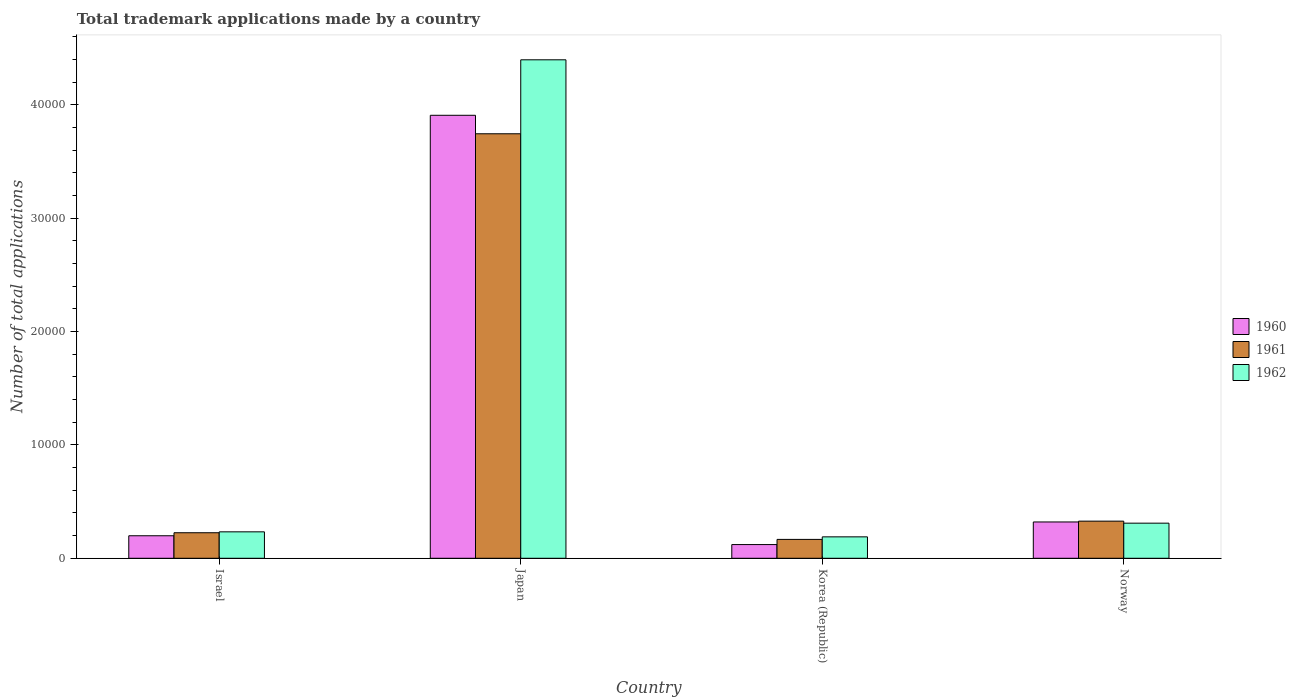How many groups of bars are there?
Ensure brevity in your answer.  4. Are the number of bars on each tick of the X-axis equal?
Your answer should be very brief. Yes. How many bars are there on the 4th tick from the right?
Offer a very short reply. 3. What is the label of the 1st group of bars from the left?
Your response must be concise. Israel. What is the number of applications made by in 1960 in Korea (Republic)?
Your response must be concise. 1209. Across all countries, what is the maximum number of applications made by in 1962?
Give a very brief answer. 4.40e+04. Across all countries, what is the minimum number of applications made by in 1960?
Your answer should be compact. 1209. In which country was the number of applications made by in 1960 minimum?
Ensure brevity in your answer.  Korea (Republic). What is the total number of applications made by in 1962 in the graph?
Keep it short and to the point. 5.13e+04. What is the difference between the number of applications made by in 1962 in Israel and that in Japan?
Keep it short and to the point. -4.17e+04. What is the difference between the number of applications made by in 1961 in Israel and the number of applications made by in 1960 in Norway?
Your answer should be very brief. -952. What is the average number of applications made by in 1962 per country?
Make the answer very short. 1.28e+04. What is the difference between the number of applications made by of/in 1960 and number of applications made by of/in 1961 in Israel?
Your answer should be compact. -266. In how many countries, is the number of applications made by in 1961 greater than 34000?
Make the answer very short. 1. What is the ratio of the number of applications made by in 1961 in Israel to that in Japan?
Your answer should be compact. 0.06. Is the difference between the number of applications made by in 1960 in Japan and Korea (Republic) greater than the difference between the number of applications made by in 1961 in Japan and Korea (Republic)?
Offer a very short reply. Yes. What is the difference between the highest and the second highest number of applications made by in 1960?
Make the answer very short. 3.71e+04. What is the difference between the highest and the lowest number of applications made by in 1961?
Keep it short and to the point. 3.58e+04. In how many countries, is the number of applications made by in 1960 greater than the average number of applications made by in 1960 taken over all countries?
Offer a terse response. 1. What does the 1st bar from the right in Israel represents?
Offer a terse response. 1962. Is it the case that in every country, the sum of the number of applications made by in 1960 and number of applications made by in 1962 is greater than the number of applications made by in 1961?
Offer a terse response. Yes. Are all the bars in the graph horizontal?
Your answer should be compact. No. How many countries are there in the graph?
Offer a very short reply. 4. What is the difference between two consecutive major ticks on the Y-axis?
Keep it short and to the point. 10000. Are the values on the major ticks of Y-axis written in scientific E-notation?
Your answer should be compact. No. Does the graph contain grids?
Your response must be concise. No. Where does the legend appear in the graph?
Make the answer very short. Center right. What is the title of the graph?
Provide a succinct answer. Total trademark applications made by a country. Does "1987" appear as one of the legend labels in the graph?
Make the answer very short. No. What is the label or title of the Y-axis?
Keep it short and to the point. Number of total applications. What is the Number of total applications in 1960 in Israel?
Your response must be concise. 1986. What is the Number of total applications in 1961 in Israel?
Your answer should be very brief. 2252. What is the Number of total applications in 1962 in Israel?
Your response must be concise. 2332. What is the Number of total applications of 1960 in Japan?
Make the answer very short. 3.91e+04. What is the Number of total applications of 1961 in Japan?
Your response must be concise. 3.75e+04. What is the Number of total applications of 1962 in Japan?
Offer a terse response. 4.40e+04. What is the Number of total applications in 1960 in Korea (Republic)?
Ensure brevity in your answer.  1209. What is the Number of total applications of 1961 in Korea (Republic)?
Your response must be concise. 1665. What is the Number of total applications of 1962 in Korea (Republic)?
Your answer should be very brief. 1890. What is the Number of total applications in 1960 in Norway?
Ensure brevity in your answer.  3204. What is the Number of total applications of 1961 in Norway?
Ensure brevity in your answer.  3276. What is the Number of total applications in 1962 in Norway?
Provide a short and direct response. 3098. Across all countries, what is the maximum Number of total applications in 1960?
Your response must be concise. 3.91e+04. Across all countries, what is the maximum Number of total applications of 1961?
Offer a very short reply. 3.75e+04. Across all countries, what is the maximum Number of total applications of 1962?
Keep it short and to the point. 4.40e+04. Across all countries, what is the minimum Number of total applications in 1960?
Give a very brief answer. 1209. Across all countries, what is the minimum Number of total applications in 1961?
Provide a short and direct response. 1665. Across all countries, what is the minimum Number of total applications in 1962?
Your answer should be compact. 1890. What is the total Number of total applications of 1960 in the graph?
Your response must be concise. 4.55e+04. What is the total Number of total applications of 1961 in the graph?
Your answer should be very brief. 4.47e+04. What is the total Number of total applications in 1962 in the graph?
Your answer should be very brief. 5.13e+04. What is the difference between the Number of total applications in 1960 in Israel and that in Japan?
Offer a very short reply. -3.71e+04. What is the difference between the Number of total applications of 1961 in Israel and that in Japan?
Your answer should be very brief. -3.52e+04. What is the difference between the Number of total applications of 1962 in Israel and that in Japan?
Your response must be concise. -4.17e+04. What is the difference between the Number of total applications in 1960 in Israel and that in Korea (Republic)?
Offer a terse response. 777. What is the difference between the Number of total applications of 1961 in Israel and that in Korea (Republic)?
Give a very brief answer. 587. What is the difference between the Number of total applications in 1962 in Israel and that in Korea (Republic)?
Make the answer very short. 442. What is the difference between the Number of total applications in 1960 in Israel and that in Norway?
Your answer should be very brief. -1218. What is the difference between the Number of total applications in 1961 in Israel and that in Norway?
Your answer should be very brief. -1024. What is the difference between the Number of total applications of 1962 in Israel and that in Norway?
Your answer should be compact. -766. What is the difference between the Number of total applications in 1960 in Japan and that in Korea (Republic)?
Give a very brief answer. 3.79e+04. What is the difference between the Number of total applications in 1961 in Japan and that in Korea (Republic)?
Offer a very short reply. 3.58e+04. What is the difference between the Number of total applications of 1962 in Japan and that in Korea (Republic)?
Provide a short and direct response. 4.21e+04. What is the difference between the Number of total applications in 1960 in Japan and that in Norway?
Ensure brevity in your answer.  3.59e+04. What is the difference between the Number of total applications in 1961 in Japan and that in Norway?
Offer a terse response. 3.42e+04. What is the difference between the Number of total applications of 1962 in Japan and that in Norway?
Your answer should be compact. 4.09e+04. What is the difference between the Number of total applications of 1960 in Korea (Republic) and that in Norway?
Your answer should be very brief. -1995. What is the difference between the Number of total applications in 1961 in Korea (Republic) and that in Norway?
Offer a terse response. -1611. What is the difference between the Number of total applications of 1962 in Korea (Republic) and that in Norway?
Keep it short and to the point. -1208. What is the difference between the Number of total applications in 1960 in Israel and the Number of total applications in 1961 in Japan?
Give a very brief answer. -3.55e+04. What is the difference between the Number of total applications in 1960 in Israel and the Number of total applications in 1962 in Japan?
Ensure brevity in your answer.  -4.20e+04. What is the difference between the Number of total applications in 1961 in Israel and the Number of total applications in 1962 in Japan?
Offer a terse response. -4.17e+04. What is the difference between the Number of total applications of 1960 in Israel and the Number of total applications of 1961 in Korea (Republic)?
Offer a terse response. 321. What is the difference between the Number of total applications in 1960 in Israel and the Number of total applications in 1962 in Korea (Republic)?
Keep it short and to the point. 96. What is the difference between the Number of total applications of 1961 in Israel and the Number of total applications of 1962 in Korea (Republic)?
Your answer should be compact. 362. What is the difference between the Number of total applications of 1960 in Israel and the Number of total applications of 1961 in Norway?
Your response must be concise. -1290. What is the difference between the Number of total applications of 1960 in Israel and the Number of total applications of 1962 in Norway?
Ensure brevity in your answer.  -1112. What is the difference between the Number of total applications in 1961 in Israel and the Number of total applications in 1962 in Norway?
Provide a succinct answer. -846. What is the difference between the Number of total applications in 1960 in Japan and the Number of total applications in 1961 in Korea (Republic)?
Your answer should be very brief. 3.74e+04. What is the difference between the Number of total applications of 1960 in Japan and the Number of total applications of 1962 in Korea (Republic)?
Make the answer very short. 3.72e+04. What is the difference between the Number of total applications of 1961 in Japan and the Number of total applications of 1962 in Korea (Republic)?
Offer a terse response. 3.56e+04. What is the difference between the Number of total applications in 1960 in Japan and the Number of total applications in 1961 in Norway?
Offer a terse response. 3.58e+04. What is the difference between the Number of total applications in 1960 in Japan and the Number of total applications in 1962 in Norway?
Your response must be concise. 3.60e+04. What is the difference between the Number of total applications of 1961 in Japan and the Number of total applications of 1962 in Norway?
Make the answer very short. 3.44e+04. What is the difference between the Number of total applications in 1960 in Korea (Republic) and the Number of total applications in 1961 in Norway?
Keep it short and to the point. -2067. What is the difference between the Number of total applications in 1960 in Korea (Republic) and the Number of total applications in 1962 in Norway?
Make the answer very short. -1889. What is the difference between the Number of total applications in 1961 in Korea (Republic) and the Number of total applications in 1962 in Norway?
Make the answer very short. -1433. What is the average Number of total applications in 1960 per country?
Make the answer very short. 1.14e+04. What is the average Number of total applications in 1961 per country?
Make the answer very short. 1.12e+04. What is the average Number of total applications in 1962 per country?
Your answer should be very brief. 1.28e+04. What is the difference between the Number of total applications of 1960 and Number of total applications of 1961 in Israel?
Your answer should be very brief. -266. What is the difference between the Number of total applications of 1960 and Number of total applications of 1962 in Israel?
Offer a very short reply. -346. What is the difference between the Number of total applications of 1961 and Number of total applications of 1962 in Israel?
Ensure brevity in your answer.  -80. What is the difference between the Number of total applications in 1960 and Number of total applications in 1961 in Japan?
Your response must be concise. 1631. What is the difference between the Number of total applications in 1960 and Number of total applications in 1962 in Japan?
Keep it short and to the point. -4896. What is the difference between the Number of total applications of 1961 and Number of total applications of 1962 in Japan?
Your answer should be compact. -6527. What is the difference between the Number of total applications of 1960 and Number of total applications of 1961 in Korea (Republic)?
Your response must be concise. -456. What is the difference between the Number of total applications of 1960 and Number of total applications of 1962 in Korea (Republic)?
Provide a succinct answer. -681. What is the difference between the Number of total applications of 1961 and Number of total applications of 1962 in Korea (Republic)?
Provide a short and direct response. -225. What is the difference between the Number of total applications in 1960 and Number of total applications in 1961 in Norway?
Offer a very short reply. -72. What is the difference between the Number of total applications in 1960 and Number of total applications in 1962 in Norway?
Ensure brevity in your answer.  106. What is the difference between the Number of total applications in 1961 and Number of total applications in 1962 in Norway?
Your response must be concise. 178. What is the ratio of the Number of total applications in 1960 in Israel to that in Japan?
Offer a very short reply. 0.05. What is the ratio of the Number of total applications of 1961 in Israel to that in Japan?
Offer a terse response. 0.06. What is the ratio of the Number of total applications in 1962 in Israel to that in Japan?
Offer a very short reply. 0.05. What is the ratio of the Number of total applications in 1960 in Israel to that in Korea (Republic)?
Your response must be concise. 1.64. What is the ratio of the Number of total applications of 1961 in Israel to that in Korea (Republic)?
Make the answer very short. 1.35. What is the ratio of the Number of total applications of 1962 in Israel to that in Korea (Republic)?
Your answer should be compact. 1.23. What is the ratio of the Number of total applications of 1960 in Israel to that in Norway?
Your response must be concise. 0.62. What is the ratio of the Number of total applications of 1961 in Israel to that in Norway?
Offer a very short reply. 0.69. What is the ratio of the Number of total applications of 1962 in Israel to that in Norway?
Provide a short and direct response. 0.75. What is the ratio of the Number of total applications in 1960 in Japan to that in Korea (Republic)?
Offer a terse response. 32.33. What is the ratio of the Number of total applications in 1961 in Japan to that in Korea (Republic)?
Your answer should be very brief. 22.5. What is the ratio of the Number of total applications in 1962 in Japan to that in Korea (Republic)?
Offer a terse response. 23.27. What is the ratio of the Number of total applications in 1960 in Japan to that in Norway?
Offer a terse response. 12.2. What is the ratio of the Number of total applications in 1961 in Japan to that in Norway?
Make the answer very short. 11.43. What is the ratio of the Number of total applications of 1962 in Japan to that in Norway?
Give a very brief answer. 14.2. What is the ratio of the Number of total applications of 1960 in Korea (Republic) to that in Norway?
Your answer should be very brief. 0.38. What is the ratio of the Number of total applications of 1961 in Korea (Republic) to that in Norway?
Keep it short and to the point. 0.51. What is the ratio of the Number of total applications in 1962 in Korea (Republic) to that in Norway?
Provide a short and direct response. 0.61. What is the difference between the highest and the second highest Number of total applications of 1960?
Offer a very short reply. 3.59e+04. What is the difference between the highest and the second highest Number of total applications in 1961?
Your answer should be very brief. 3.42e+04. What is the difference between the highest and the second highest Number of total applications in 1962?
Make the answer very short. 4.09e+04. What is the difference between the highest and the lowest Number of total applications of 1960?
Your answer should be very brief. 3.79e+04. What is the difference between the highest and the lowest Number of total applications of 1961?
Your answer should be very brief. 3.58e+04. What is the difference between the highest and the lowest Number of total applications in 1962?
Your response must be concise. 4.21e+04. 